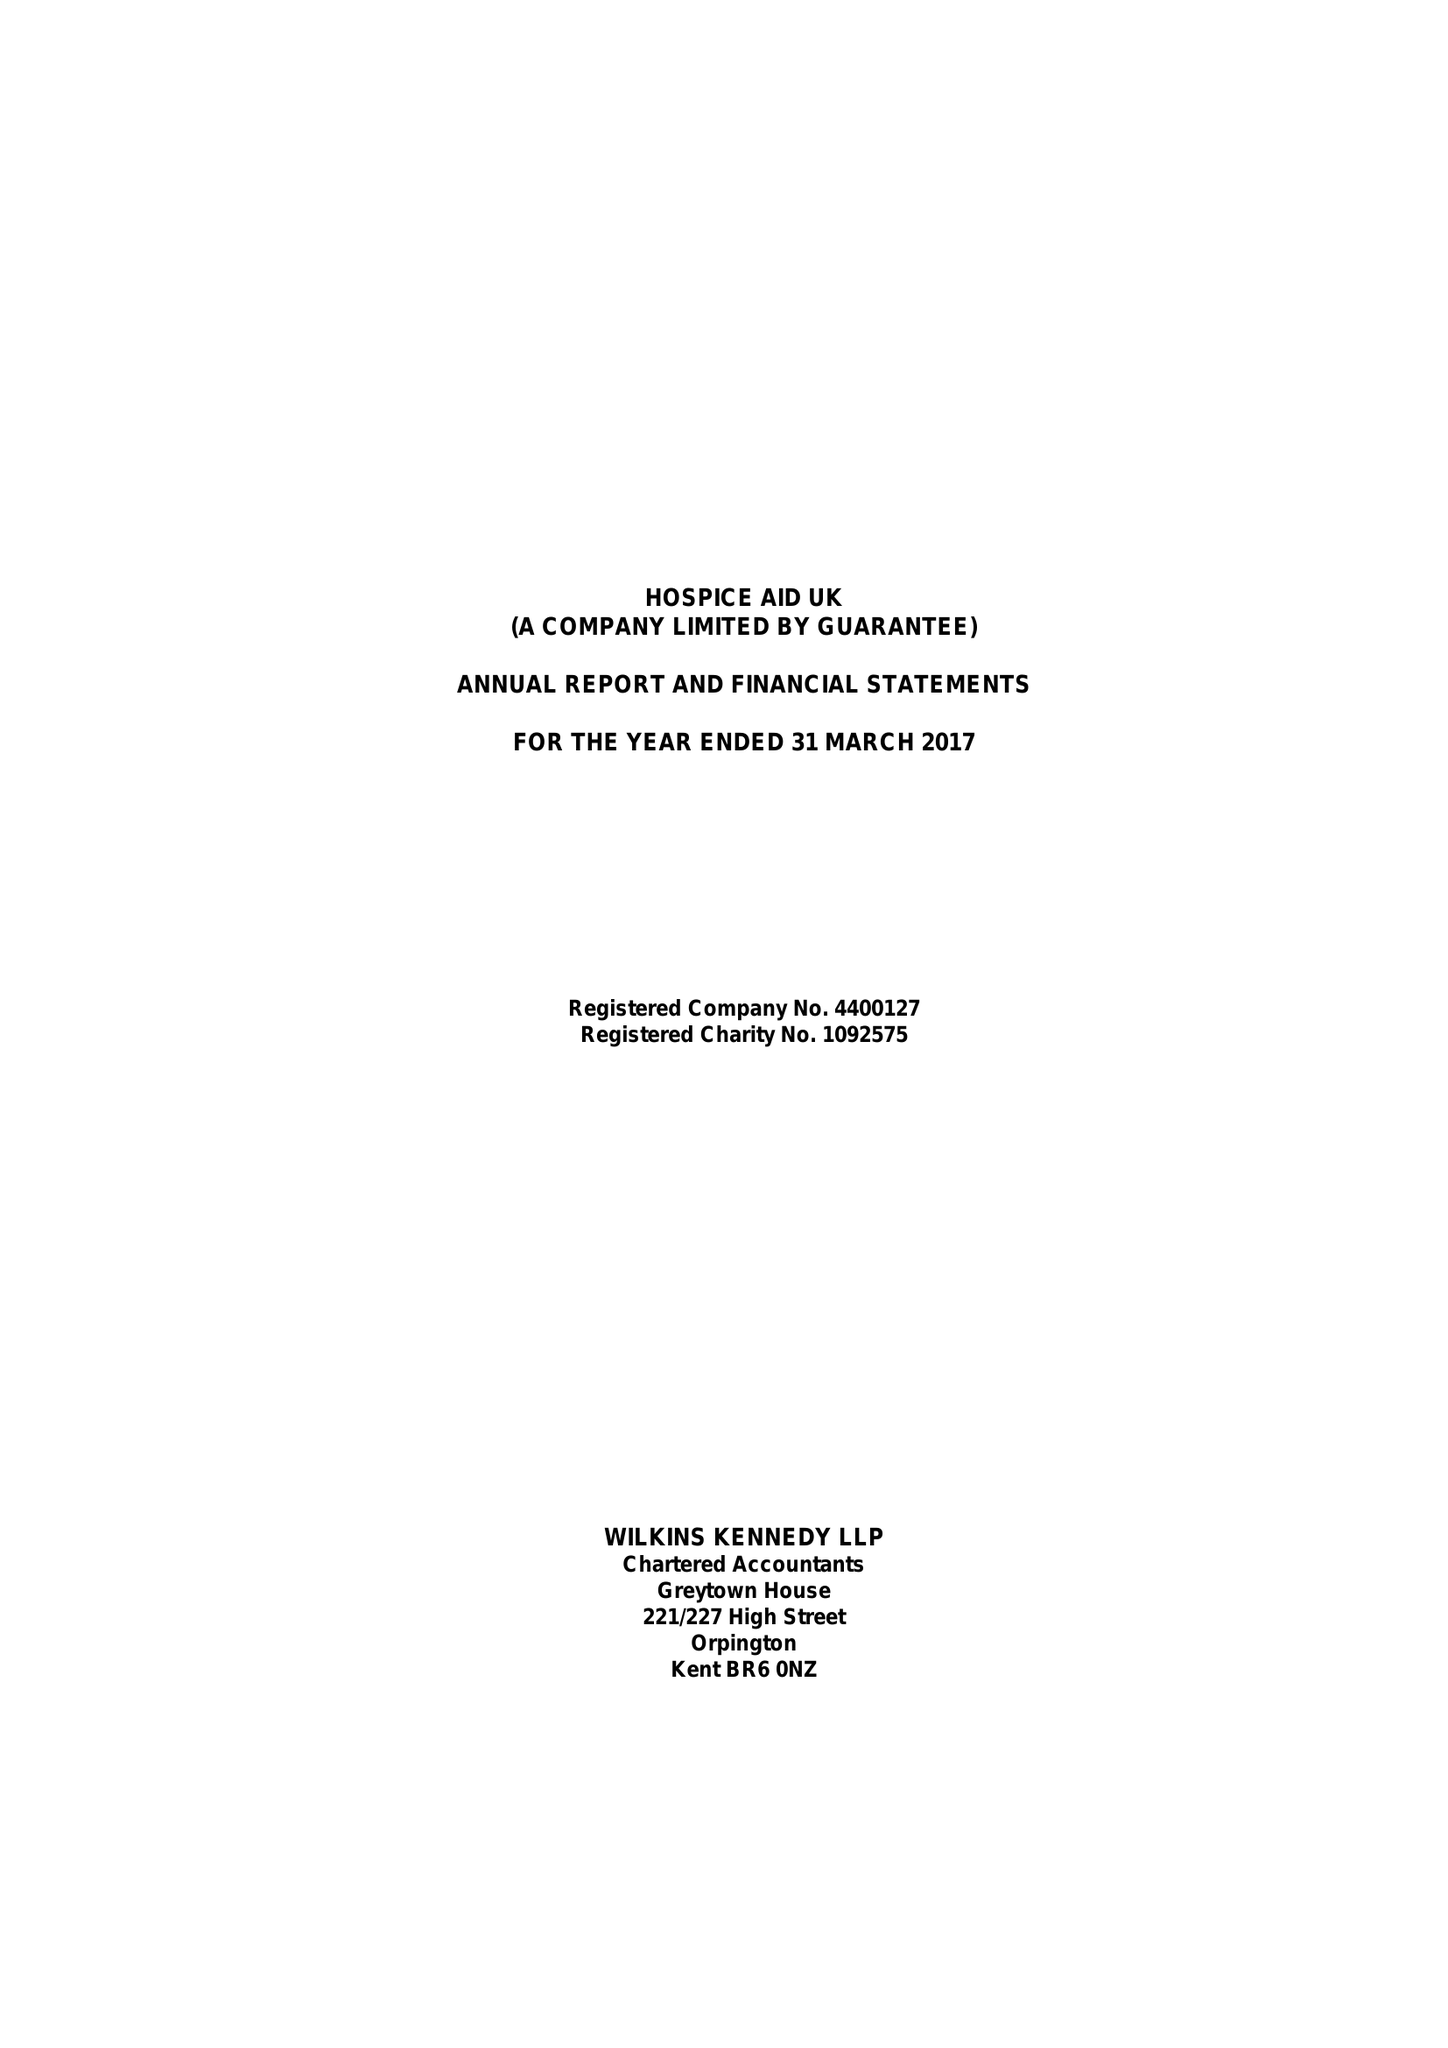What is the value for the address__street_line?
Answer the question using a single word or phrase. 1-7 STATION ROAD 